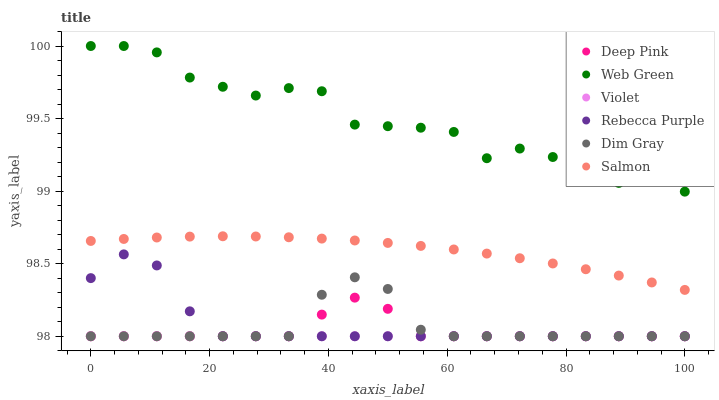Does Violet have the minimum area under the curve?
Answer yes or no. Yes. Does Web Green have the maximum area under the curve?
Answer yes or no. Yes. Does Salmon have the minimum area under the curve?
Answer yes or no. No. Does Salmon have the maximum area under the curve?
Answer yes or no. No. Is Violet the smoothest?
Answer yes or no. Yes. Is Web Green the roughest?
Answer yes or no. Yes. Is Salmon the smoothest?
Answer yes or no. No. Is Salmon the roughest?
Answer yes or no. No. Does Dim Gray have the lowest value?
Answer yes or no. Yes. Does Salmon have the lowest value?
Answer yes or no. No. Does Web Green have the highest value?
Answer yes or no. Yes. Does Salmon have the highest value?
Answer yes or no. No. Is Rebecca Purple less than Web Green?
Answer yes or no. Yes. Is Web Green greater than Violet?
Answer yes or no. Yes. Does Rebecca Purple intersect Dim Gray?
Answer yes or no. Yes. Is Rebecca Purple less than Dim Gray?
Answer yes or no. No. Is Rebecca Purple greater than Dim Gray?
Answer yes or no. No. Does Rebecca Purple intersect Web Green?
Answer yes or no. No. 